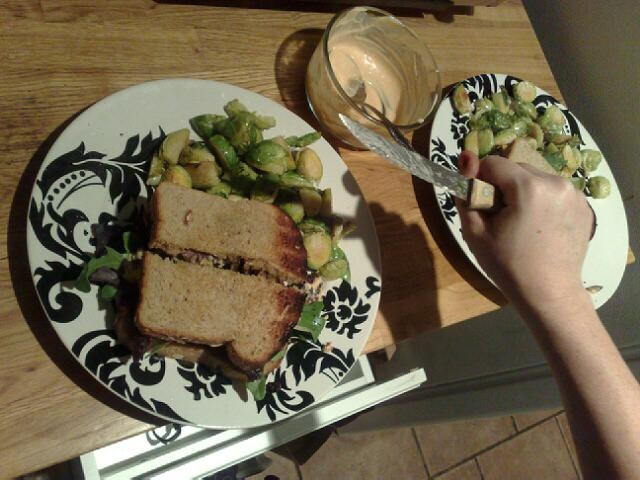Describe the objects in this image and their specific colors. I can see dining table in gray, olive, and black tones, sandwich in gray, olive, tan, black, and brown tones, people in gray, tan, and black tones, bowl in gray, olive, and tan tones, and knife in gray, darkgray, and black tones in this image. 